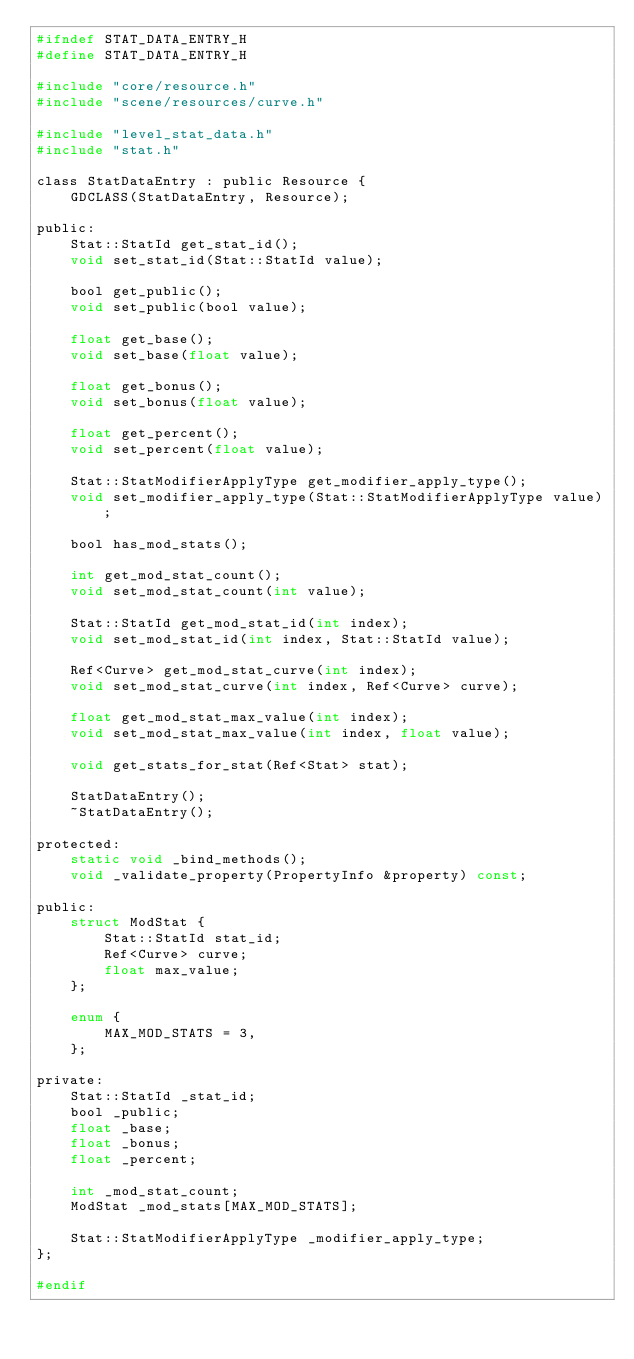Convert code to text. <code><loc_0><loc_0><loc_500><loc_500><_C_>#ifndef STAT_DATA_ENTRY_H
#define STAT_DATA_ENTRY_H

#include "core/resource.h"
#include "scene/resources/curve.h"

#include "level_stat_data.h"
#include "stat.h"

class StatDataEntry : public Resource {
	GDCLASS(StatDataEntry, Resource);

public:
	Stat::StatId get_stat_id();
	void set_stat_id(Stat::StatId value);

	bool get_public();
	void set_public(bool value);

	float get_base();
	void set_base(float value);

	float get_bonus();
	void set_bonus(float value);

	float get_percent();
	void set_percent(float value);

	Stat::StatModifierApplyType get_modifier_apply_type();
	void set_modifier_apply_type(Stat::StatModifierApplyType value);

	bool has_mod_stats();

	int get_mod_stat_count();
	void set_mod_stat_count(int value);

	Stat::StatId get_mod_stat_id(int index);
	void set_mod_stat_id(int index, Stat::StatId value);

	Ref<Curve> get_mod_stat_curve(int index);
	void set_mod_stat_curve(int index, Ref<Curve> curve);

	float get_mod_stat_max_value(int index);
	void set_mod_stat_max_value(int index, float value);

	void get_stats_for_stat(Ref<Stat> stat);

	StatDataEntry();
	~StatDataEntry();

protected:
	static void _bind_methods();
	void _validate_property(PropertyInfo &property) const;

public:
	struct ModStat {
		Stat::StatId stat_id;
		Ref<Curve> curve;
		float max_value;
	};

	enum {
		MAX_MOD_STATS = 3,
	};

private:
	Stat::StatId _stat_id;
	bool _public;
	float _base;
	float _bonus;
	float _percent;

	int _mod_stat_count;
	ModStat _mod_stats[MAX_MOD_STATS];

	Stat::StatModifierApplyType _modifier_apply_type;
};

#endif
</code> 